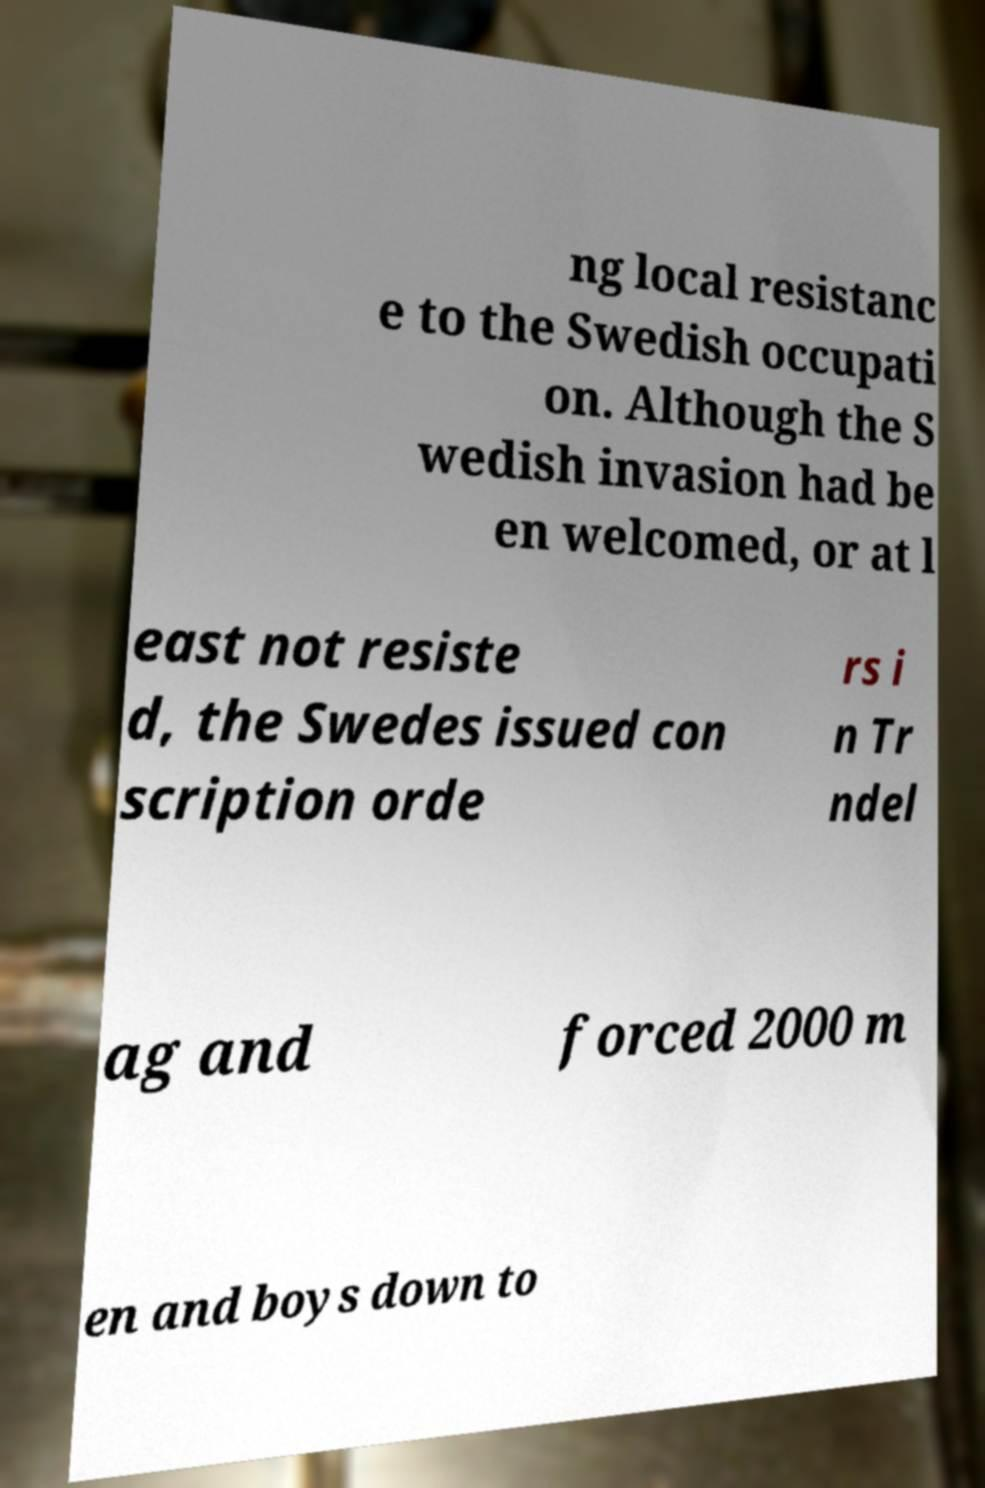Please read and relay the text visible in this image. What does it say? ng local resistanc e to the Swedish occupati on. Although the S wedish invasion had be en welcomed, or at l east not resiste d, the Swedes issued con scription orde rs i n Tr ndel ag and forced 2000 m en and boys down to 